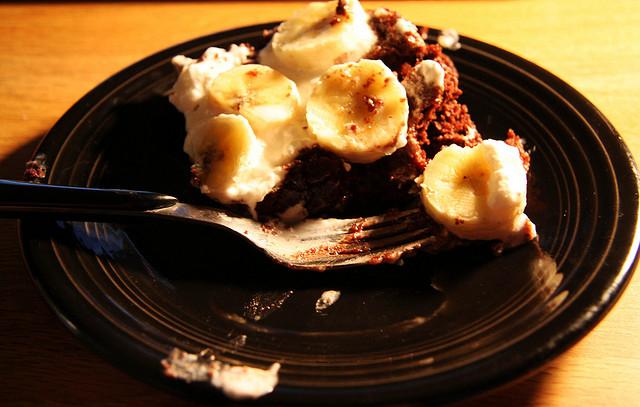Is this a clean fork?
Keep it brief. No. Was another course served after this dish?
Write a very short answer. No. What food is shown?
Short answer required. Bananas. 